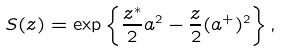Convert formula to latex. <formula><loc_0><loc_0><loc_500><loc_500>S ( z ) = \exp \left \{ \frac { z ^ { * } } { 2 } a ^ { 2 } - \frac { z } { 2 } ( a ^ { + } ) ^ { 2 } \right \} ,</formula> 